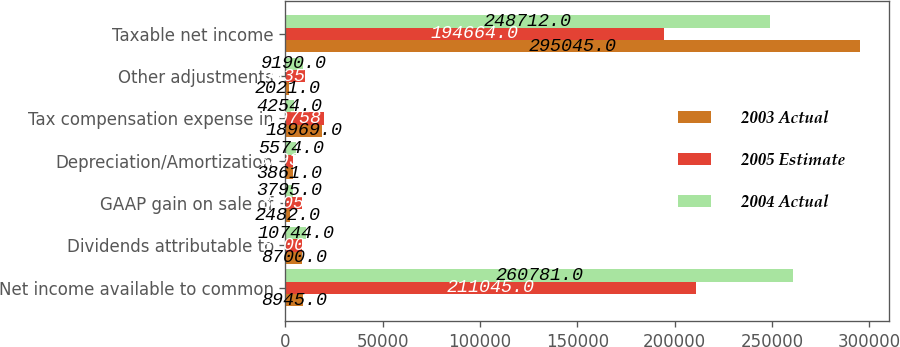Convert chart to OTSL. <chart><loc_0><loc_0><loc_500><loc_500><stacked_bar_chart><ecel><fcel>Net income available to common<fcel>Dividends attributable to<fcel>GAAP gain on sale of<fcel>Depreciation/Amortization<fcel>Tax compensation expense in<fcel>Other adjustments<fcel>Taxable net income<nl><fcel>2003 Actual<fcel>8945<fcel>8700<fcel>2482<fcel>3861<fcel>18969<fcel>2021<fcel>295045<nl><fcel>2005 Estimate<fcel>211045<fcel>8700<fcel>8305<fcel>3793<fcel>19758<fcel>9835<fcel>194664<nl><fcel>2004 Actual<fcel>260781<fcel>10744<fcel>3795<fcel>5574<fcel>4254<fcel>9190<fcel>248712<nl></chart> 